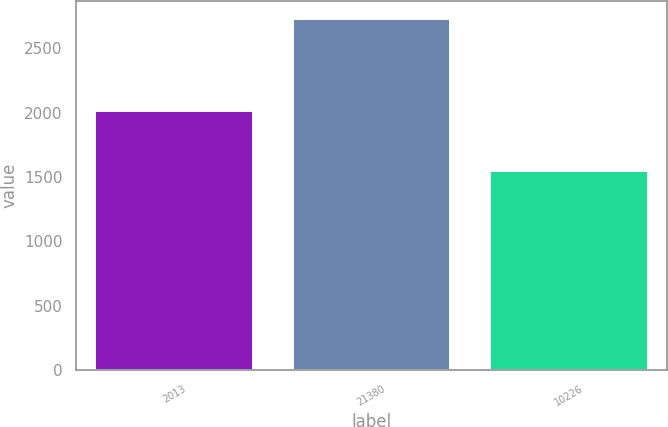<chart> <loc_0><loc_0><loc_500><loc_500><bar_chart><fcel>2013<fcel>21380<fcel>10226<nl><fcel>2012<fcel>2730.3<fcel>1547.2<nl></chart> 